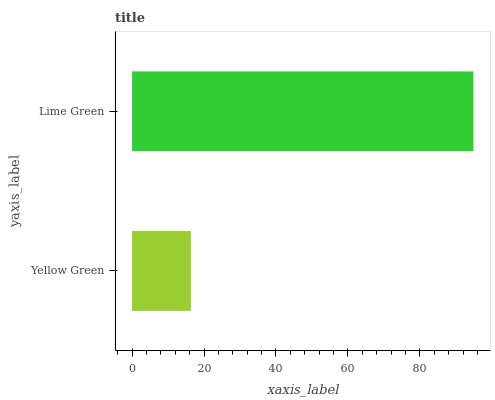Is Yellow Green the minimum?
Answer yes or no. Yes. Is Lime Green the maximum?
Answer yes or no. Yes. Is Lime Green the minimum?
Answer yes or no. No. Is Lime Green greater than Yellow Green?
Answer yes or no. Yes. Is Yellow Green less than Lime Green?
Answer yes or no. Yes. Is Yellow Green greater than Lime Green?
Answer yes or no. No. Is Lime Green less than Yellow Green?
Answer yes or no. No. Is Lime Green the high median?
Answer yes or no. Yes. Is Yellow Green the low median?
Answer yes or no. Yes. Is Yellow Green the high median?
Answer yes or no. No. Is Lime Green the low median?
Answer yes or no. No. 